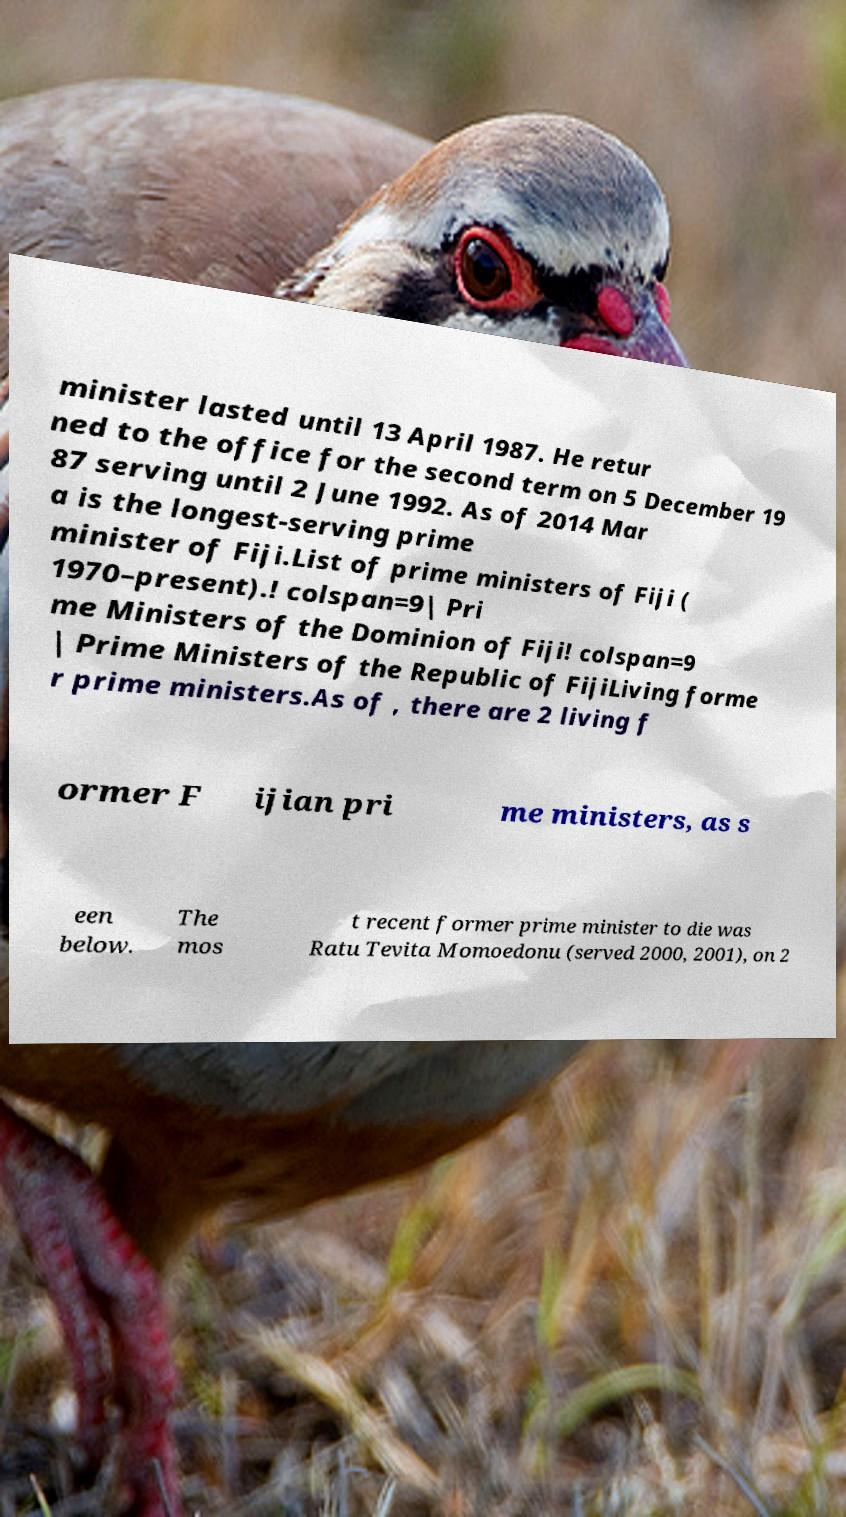Could you assist in decoding the text presented in this image and type it out clearly? minister lasted until 13 April 1987. He retur ned to the office for the second term on 5 December 19 87 serving until 2 June 1992. As of 2014 Mar a is the longest-serving prime minister of Fiji.List of prime ministers of Fiji ( 1970–present).! colspan=9| Pri me Ministers of the Dominion of Fiji! colspan=9 | Prime Ministers of the Republic of FijiLiving forme r prime ministers.As of , there are 2 living f ormer F ijian pri me ministers, as s een below. The mos t recent former prime minister to die was Ratu Tevita Momoedonu (served 2000, 2001), on 2 